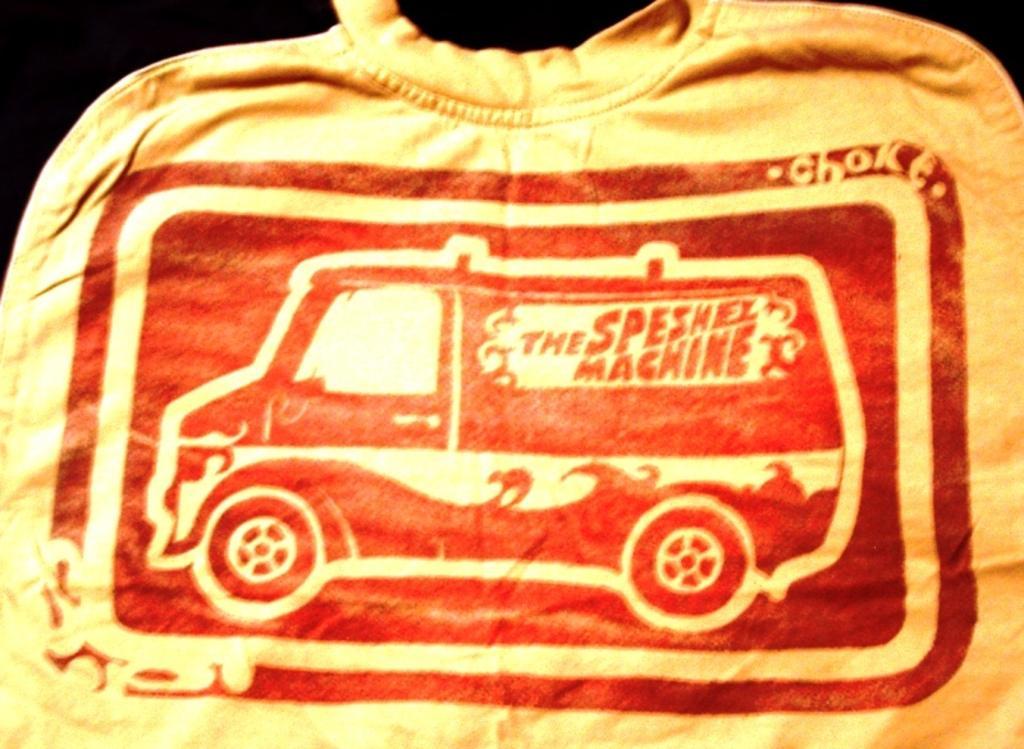Could you give a brief overview of what you see in this image? In this image we can see a t-shirt with the picture of a truck and some text on it. 